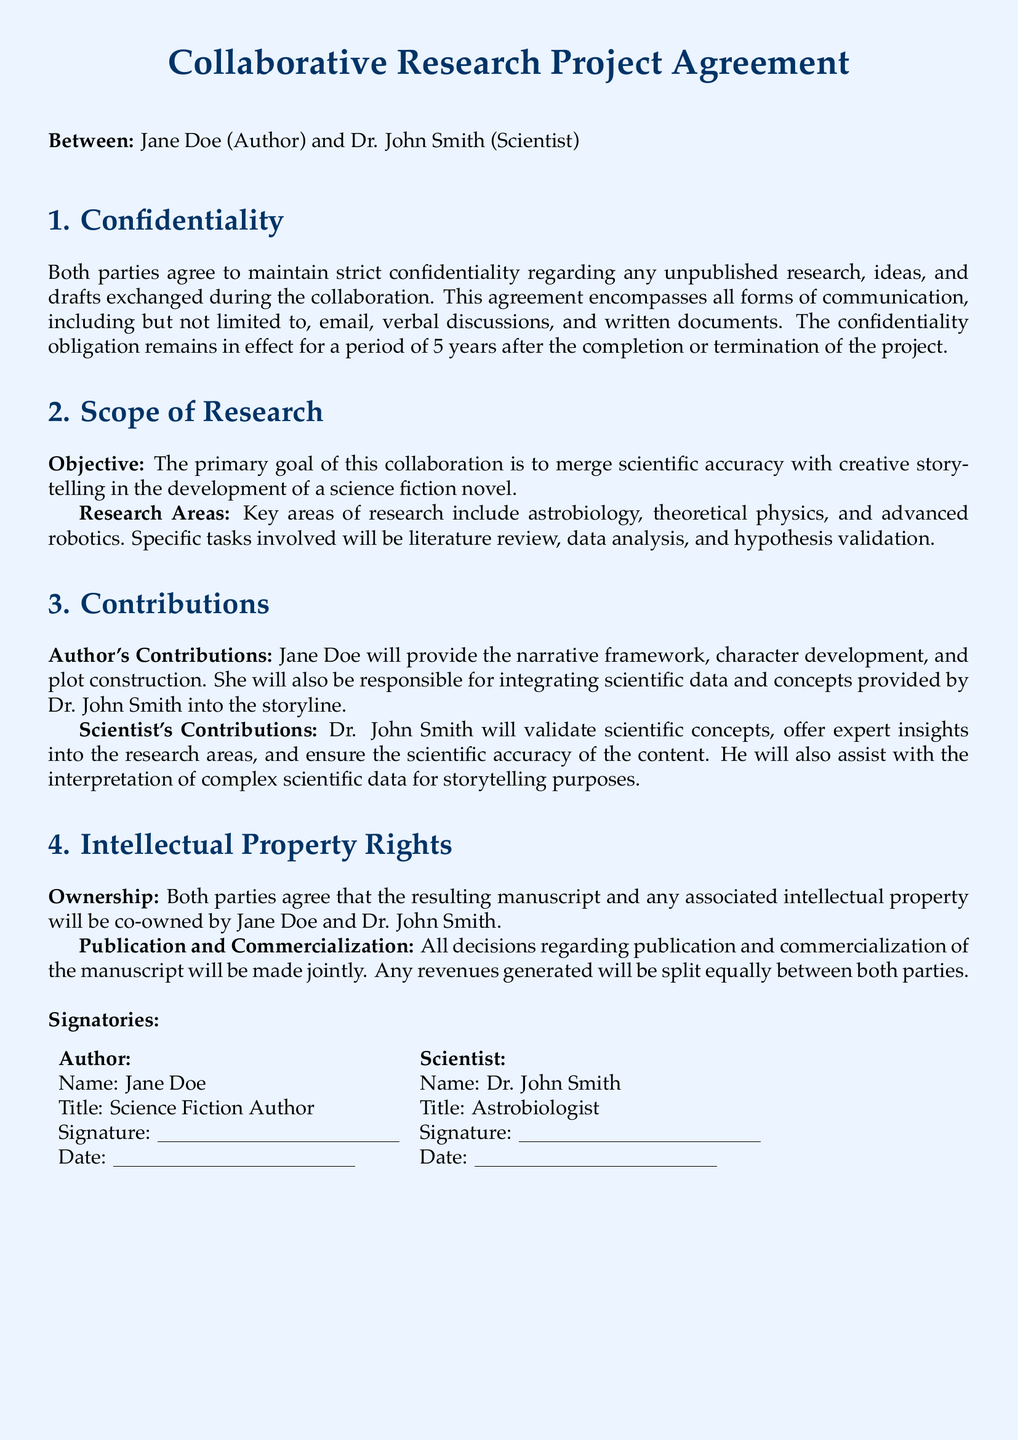what is the primary goal of the collaboration? The primary goal is stated in the "Scope of Research" section as merging scientific accuracy with creative storytelling in the development of a science fiction novel.
Answer: merging scientific accuracy with creative storytelling who are the two parties involved in this agreement? The document specifies that the two parties are Jane Doe and Dr. John Smith.
Answer: Jane Doe and Dr. John Smith how long does the confidentiality obligation last after project completion? The confidentiality section mentions that the obligation lasts for a period of 5 years after completion or termination of the project.
Answer: 5 years what are the key areas of research mentioned? The document lists astrobiology, theoretical physics, and advanced robotics as key areas of research in the "Scope of Research" section.
Answer: astrobiology, theoretical physics, and advanced robotics how will revenues from the manuscript be shared? The "Intellectual Property Rights" section states that revenues generated will be split equally between both parties.
Answer: equally who is responsible for the integration of scientific data into the storyline? The document states that Jane Doe will be responsible for integrating scientific data and concepts into the storyline.
Answer: Jane Doe what must both parties do regarding publication decisions? The "Intellectual Property Rights" section requires that all decisions regarding publication and commercialization be made jointly by both parties.
Answer: jointly what title does Jane Doe hold? The document indicates her title as Science Fiction Author.
Answer: Science Fiction Author what actions does Dr. John Smith agree to take to ensure scientific accuracy? The document specifies that Dr. John Smith will validate scientific concepts and assist with the interpretation of complex scientific data.
Answer: validate scientific concepts and assist with interpretation 